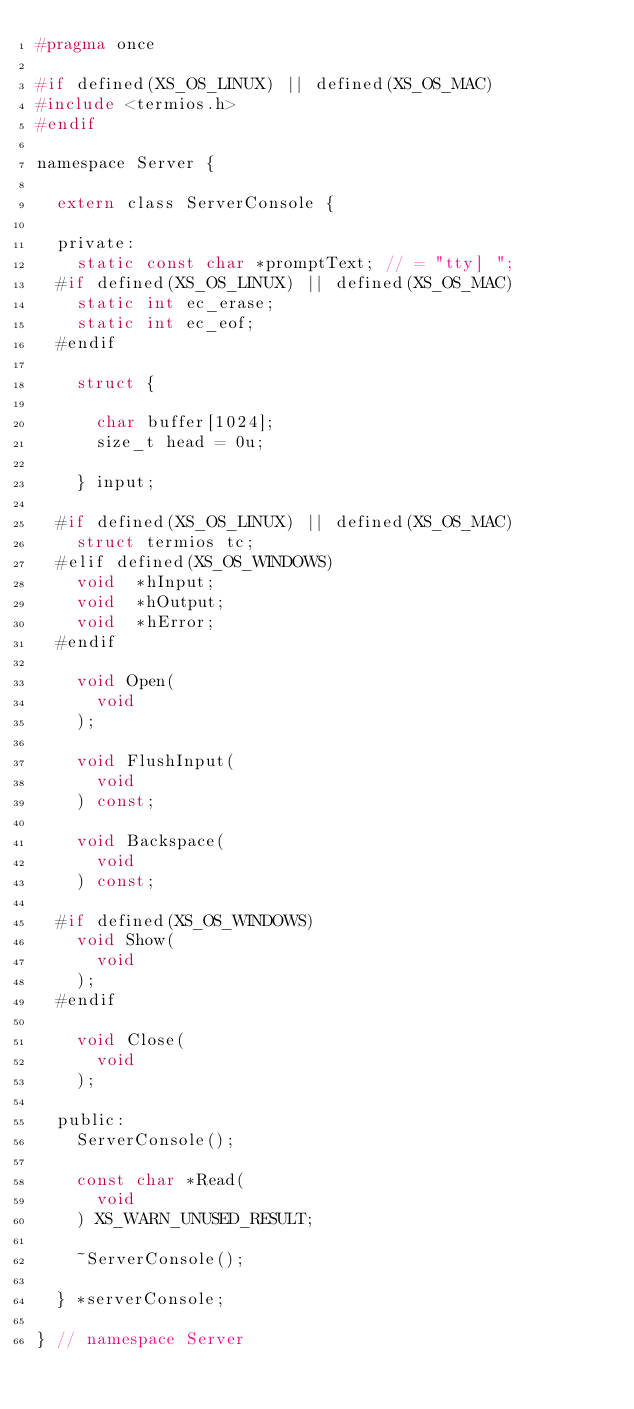<code> <loc_0><loc_0><loc_500><loc_500><_C_>#pragma once

#if defined(XS_OS_LINUX) || defined(XS_OS_MAC)
#include <termios.h>
#endif

namespace Server {

	extern class ServerConsole {

	private:
		static const char *promptText; // = "tty] ";
	#if defined(XS_OS_LINUX) || defined(XS_OS_MAC)
		static int ec_erase;
		static int ec_eof;
	#endif

		struct {

			char buffer[1024];
			size_t head = 0u;

		} input;

	#if defined(XS_OS_LINUX) || defined(XS_OS_MAC)
		struct termios tc;
	#elif defined(XS_OS_WINDOWS)
		void	*hInput;
		void	*hOutput;
		void	*hError;
	#endif

		void Open(
			void
		);

		void FlushInput(
			void
		) const;

		void Backspace(
			void
		) const;

	#if defined(XS_OS_WINDOWS)
		void Show(
			void
		);
	#endif

		void Close(
			void
		);

	public:
		ServerConsole();

		const char *Read(
			void
		) XS_WARN_UNUSED_RESULT;

		~ServerConsole();

	} *serverConsole;

} // namespace Server
</code> 